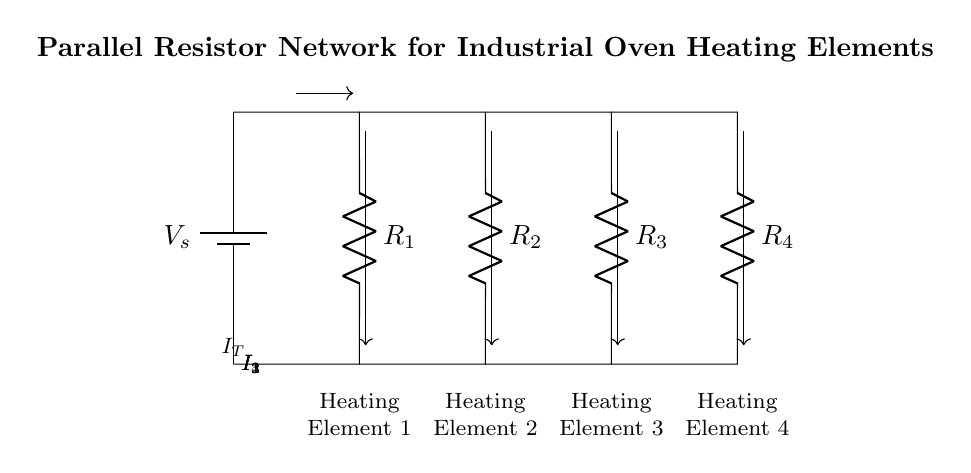What is the total voltage in the circuit? The total voltage is represented by the battery symbol labeled V_s. In a simple circuit like this with one power source, the voltage remains constant across all components.
Answer: V_s How many heating elements are present? There are four specific resistors connected in parallel, each representing a heating element in the circuit. Counting the labeled elements, we see Heating Element 1, 2, 3, and 4.
Answer: 4 What is the type of circuit configuration used here? The configuration is a parallel resistor network, indicated by multiple paths for current flow. In a parallel circuit, the voltage across all components remains the same, and they share the total current.
Answer: Parallel What is the current flowing through Heating Element 2? The diagram shows currents labeled as I_1, I_2, I_3, and I_4 through each heating element. The current through Heating Element 2 is represented by I_2, specifically marked in the diagram.
Answer: I_2 Which resistor has the highest resistance? In parallel circuits, the resistor with the highest resistance typically has the least current flowing through it. Since the resistance values aren't specified in the diagram, we assume the highest resistance corresponds to the labeled resistors. Without specific values, we cannot determine which is highest.
Answer: R_x (where x is the highest) How does the total current relate to individual currents in this circuit? The total current (I_T) entering the parallel network is the sum of the individual currents flowing through each parallel branch. This is a fundamental property of current dividers, where I_T = I_1 + I_2 + I_3 + I_4 for the individual currents denoted in the diagram.
Answer: I_T = I_1 + I_2 + I_3 + I_4 